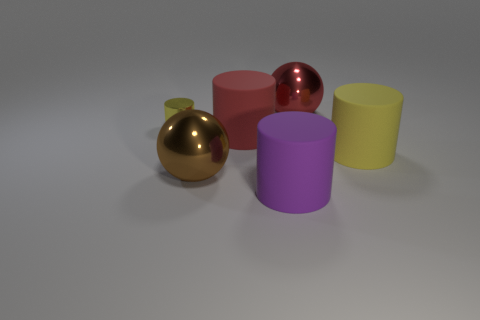There is a big thing that is the same color as the small cylinder; what is its shape?
Your response must be concise. Cylinder. Are the tiny thing and the thing behind the yellow shiny object made of the same material?
Your answer should be compact. Yes. What shape is the red thing that is the same material as the large brown object?
Your answer should be very brief. Sphere. The metal thing that is the same size as the brown ball is what color?
Keep it short and to the point. Red. Is the size of the yellow cylinder that is on the right side of the red rubber cylinder the same as the tiny cylinder?
Keep it short and to the point. No. What number of brown spheres are there?
Offer a terse response. 1. What number of spheres are brown shiny objects or small blue things?
Give a very brief answer. 1. There is a yellow cylinder that is behind the large red rubber thing; how many big red balls are in front of it?
Ensure brevity in your answer.  0. Is the big brown object made of the same material as the large purple thing?
Give a very brief answer. No. What is the size of the object that is the same color as the tiny cylinder?
Offer a terse response. Large. 